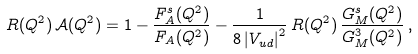Convert formula to latex. <formula><loc_0><loc_0><loc_500><loc_500>R ( Q ^ { 2 } ) \, \mathcal { A } ( Q ^ { 2 } ) = 1 - \frac { F ^ { s } _ { A } ( Q ^ { 2 } ) } { F _ { A } ( Q ^ { 2 } ) } - \frac { 1 } { 8 \left | V _ { u d } \right | ^ { 2 } } \, R ( Q ^ { 2 } ) \, \frac { G _ { M } ^ { s } ( Q ^ { 2 } ) } { G _ { M } ^ { 3 } ( Q ^ { 2 } ) } \, ,</formula> 